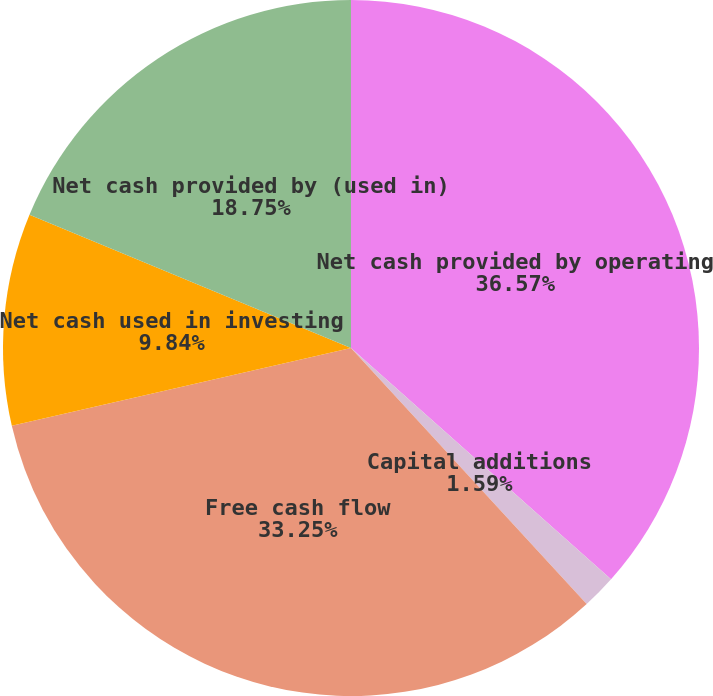Convert chart. <chart><loc_0><loc_0><loc_500><loc_500><pie_chart><fcel>Net cash provided by operating<fcel>Capital additions<fcel>Free cash flow<fcel>Net cash used in investing<fcel>Net cash provided by (used in)<nl><fcel>36.57%<fcel>1.59%<fcel>33.25%<fcel>9.84%<fcel>18.75%<nl></chart> 